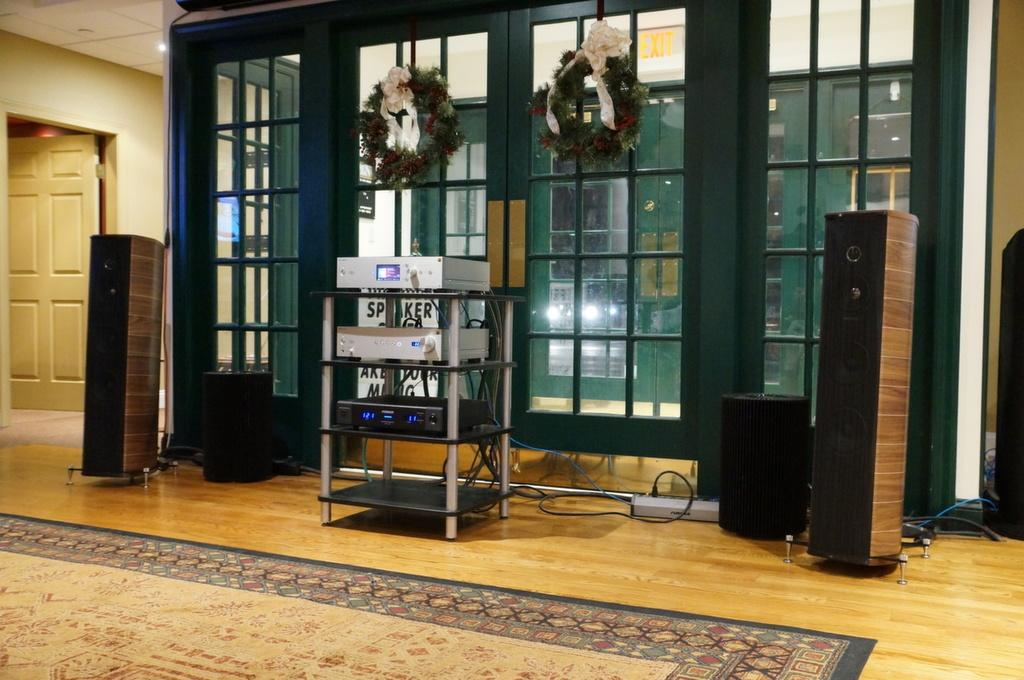What is placed on the floor in the image? There are speakers on the floor. What type of floor covering can be seen in the image? There is a floor mat in the image. What electronic devices are present in the image? There are devices present in the image. What can be used to enter or exit the room in the image? There is a door in the image. What can provide illumination in the image? There are lights in the image. What can be seen in the image besides the speakers and floor mat? There are objects in the image. What is visible in the background of the image? There is a wall and a roof in the background. What type of twig is being used as a comfort item in the image? There is no twig present in the image, and no comfort items are mentioned. What type of underwear is visible on the wall in the image? There is no underwear present in the image; only speakers, a floor mat, devices, a door, lights, objects, a wall, and a roof are visible. 